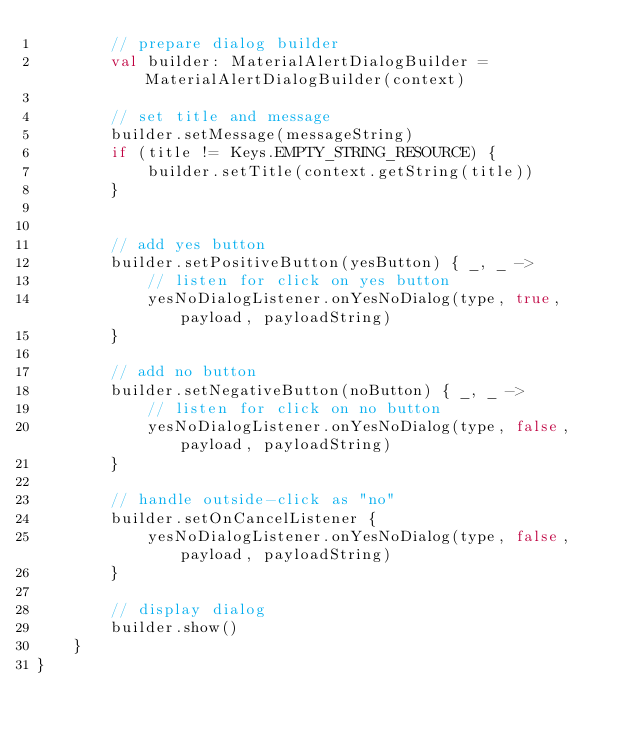Convert code to text. <code><loc_0><loc_0><loc_500><loc_500><_Kotlin_>        // prepare dialog builder
        val builder: MaterialAlertDialogBuilder = MaterialAlertDialogBuilder(context)

        // set title and message
        builder.setMessage(messageString)
        if (title != Keys.EMPTY_STRING_RESOURCE) {
            builder.setTitle(context.getString(title))
        }


        // add yes button
        builder.setPositiveButton(yesButton) { _, _ ->
            // listen for click on yes button
            yesNoDialogListener.onYesNoDialog(type, true, payload, payloadString)
        }

        // add no button
        builder.setNegativeButton(noButton) { _, _ ->
            // listen for click on no button
            yesNoDialogListener.onYesNoDialog(type, false, payload, payloadString)
        }

        // handle outside-click as "no"
        builder.setOnCancelListener {
            yesNoDialogListener.onYesNoDialog(type, false, payload, payloadString)
        }

        // display dialog
        builder.show()
    }
}</code> 